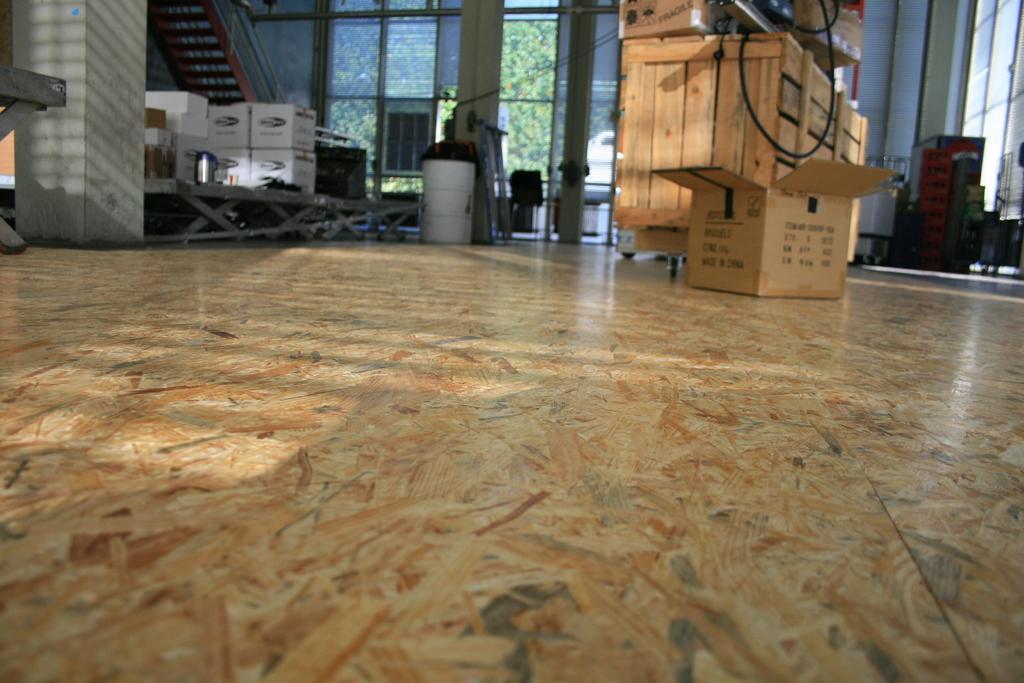Please provide a concise description of this image. As we can see in the image there is a wall, window, door, boxes and a dustbin. 